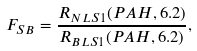Convert formula to latex. <formula><loc_0><loc_0><loc_500><loc_500>F _ { S B } = \frac { R _ { N L S 1 } ( P A H , 6 . 2 ) } { R _ { B L S 1 } ( P A H , 6 . 2 ) } ,</formula> 